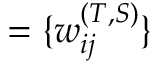<formula> <loc_0><loc_0><loc_500><loc_500>= \{ w _ { i j } ^ { ( T , S ) } \}</formula> 